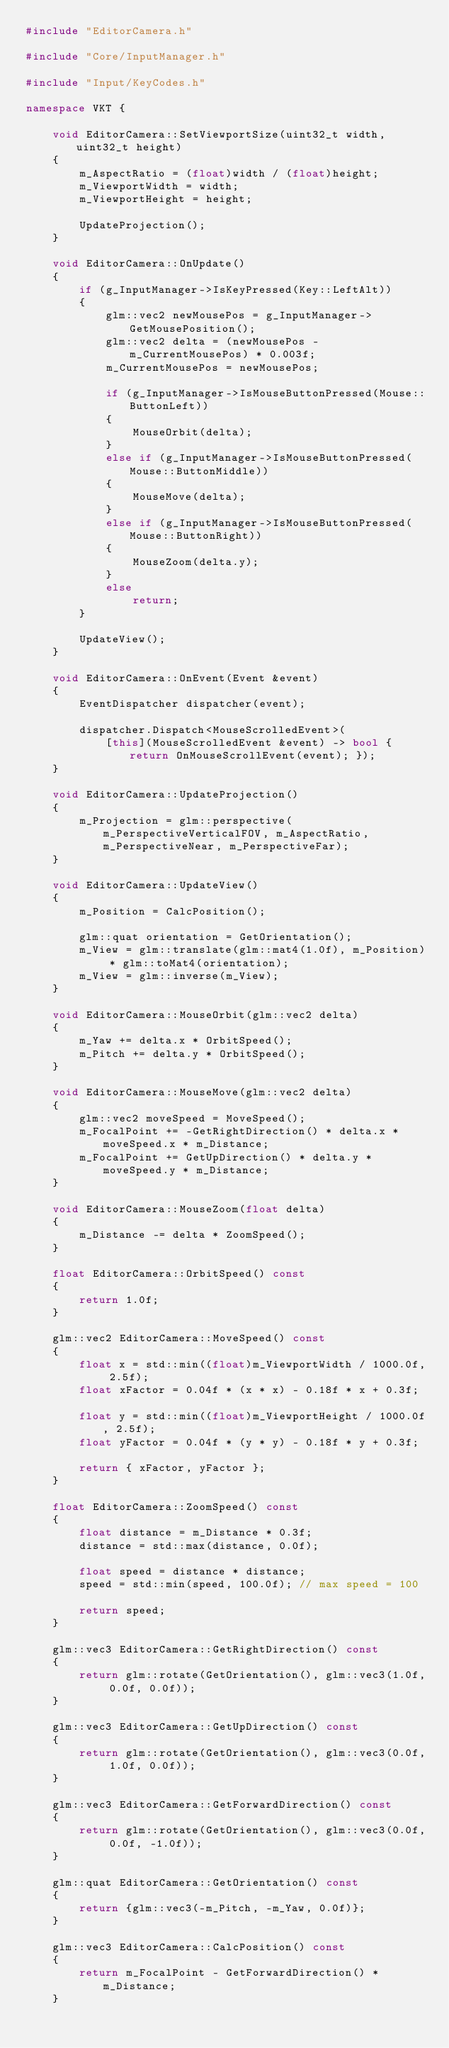Convert code to text. <code><loc_0><loc_0><loc_500><loc_500><_C++_>#include "EditorCamera.h"

#include "Core/InputManager.h"

#include "Input/KeyCodes.h"

namespace VKT {

    void EditorCamera::SetViewportSize(uint32_t width, uint32_t height)
    {
        m_AspectRatio = (float)width / (float)height;
        m_ViewportWidth = width;
        m_ViewportHeight = height;

        UpdateProjection();
    }

    void EditorCamera::OnUpdate()
    {
        if (g_InputManager->IsKeyPressed(Key::LeftAlt))
        {
            glm::vec2 newMousePos = g_InputManager->GetMousePosition();
            glm::vec2 delta = (newMousePos - m_CurrentMousePos) * 0.003f;
            m_CurrentMousePos = newMousePos;

            if (g_InputManager->IsMouseButtonPressed(Mouse::ButtonLeft))
            {
                MouseOrbit(delta);
            }
            else if (g_InputManager->IsMouseButtonPressed(Mouse::ButtonMiddle))
            {
                MouseMove(delta);
            }
            else if (g_InputManager->IsMouseButtonPressed(Mouse::ButtonRight))
            {
                MouseZoom(delta.y);
            }
            else
                return;
        }

        UpdateView();
    }

    void EditorCamera::OnEvent(Event &event)
    {
        EventDispatcher dispatcher(event);

        dispatcher.Dispatch<MouseScrolledEvent>(
            [this](MouseScrolledEvent &event) -> bool { return OnMouseScrollEvent(event); });
    }

    void EditorCamera::UpdateProjection()
    {
        m_Projection = glm::perspective(m_PerspectiveVerticalFOV, m_AspectRatio, m_PerspectiveNear, m_PerspectiveFar);
    }

    void EditorCamera::UpdateView()
    {
        m_Position = CalcPosition();

        glm::quat orientation = GetOrientation();
        m_View = glm::translate(glm::mat4(1.0f), m_Position) * glm::toMat4(orientation);
        m_View = glm::inverse(m_View);
    }

    void EditorCamera::MouseOrbit(glm::vec2 delta)
    {
        m_Yaw += delta.x * OrbitSpeed();
        m_Pitch += delta.y * OrbitSpeed();
    }

    void EditorCamera::MouseMove(glm::vec2 delta)
    {
        glm::vec2 moveSpeed = MoveSpeed();
        m_FocalPoint += -GetRightDirection() * delta.x * moveSpeed.x * m_Distance;
        m_FocalPoint += GetUpDirection() * delta.y * moveSpeed.y * m_Distance;
    }

    void EditorCamera::MouseZoom(float delta)
    {
        m_Distance -= delta * ZoomSpeed();
    }

    float EditorCamera::OrbitSpeed() const
    {
        return 1.0f;
    }

    glm::vec2 EditorCamera::MoveSpeed() const
    {
        float x = std::min((float)m_ViewportWidth / 1000.0f, 2.5f);
        float xFactor = 0.04f * (x * x) - 0.18f * x + 0.3f;

        float y = std::min((float)m_ViewportHeight / 1000.0f, 2.5f);
        float yFactor = 0.04f * (y * y) - 0.18f * y + 0.3f;

        return { xFactor, yFactor };
    }

    float EditorCamera::ZoomSpeed() const
    {
        float distance = m_Distance * 0.3f;
        distance = std::max(distance, 0.0f);

        float speed = distance * distance;
        speed = std::min(speed, 100.0f); // max speed = 100

        return speed;
    }

    glm::vec3 EditorCamera::GetRightDirection() const
    {
        return glm::rotate(GetOrientation(), glm::vec3(1.0f, 0.0f, 0.0f));
    }

    glm::vec3 EditorCamera::GetUpDirection() const
    {
        return glm::rotate(GetOrientation(), glm::vec3(0.0f, 1.0f, 0.0f));
    }

    glm::vec3 EditorCamera::GetForwardDirection() const
    {
        return glm::rotate(GetOrientation(), glm::vec3(0.0f, 0.0f, -1.0f));
    }

    glm::quat EditorCamera::GetOrientation() const
    {
        return {glm::vec3(-m_Pitch, -m_Yaw, 0.0f)};
    }

    glm::vec3 EditorCamera::CalcPosition() const
    {
        return m_FocalPoint - GetForwardDirection() * m_Distance;
    }
</code> 